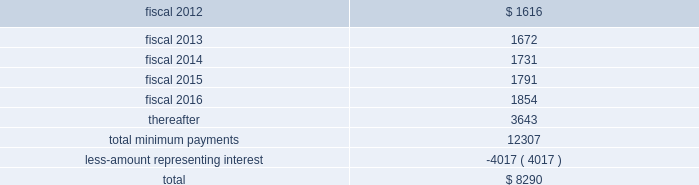Table of contents finance lease obligations the company has a non-cancelable lease agreement for a building with approximately 164000 square feet located in alajuela , costa rica , to be used as a manufacturing and office facility .
The company was responsible for a significant portion of the construction costs , and in accordance with asc 840 , leases , subsection 40-15-5 , the company was deemed to be the owner of the building during the construction period .
The building was completed in fiscal 2008 , and the company has recorded the fair market value of the building and land of $ 15.1 million within property and equipment on its consolidated balance sheets .
At september 24 , 2011 , the company has recorded $ 1.6 million in accrued expenses and $ 16.9 million in other long-term liabilities related to this obligation in the consolidated balance sheet .
The term of the lease , which commenced in may 2008 , is for a period of approximately ten years with the option to extend for two consecutive 5-year terms .
At the completion of the construction period , the company reviewed the lease for potential sale-leaseback treatment in accordance with asc 840 , subsection 40 , sale-leaseback transactions .
Based on its analysis , the company determined that the lease did not qualify for sale-leaseback treatment .
Therefore , the building , leasehold improvements and associated liabilities remain on the company 2019s financial statements throughout the lease term , and the building and leasehold improvements are being depreciated on a straight line basis over their estimated useful lives of 35 years .
Future minimum lease payments , including principal and interest , under this lease were as follows at september 24 , 2011: .
The company also has to a non-cancelable lease agreement for a building with approximately 146000 square feet located in marlborough , massachusetts , to be principally used as an additional manufacturing facility .
As part of the lease agreement , the lessor agreed to allow the company to make significant renovations to the facility to prepare the facility for the company 2019s manufacturing needs .
The company was responsible for a significant amount of the construction costs and therefore in accordance with asc 840-40-15-5 was deemed to be the owner of the building during the construction period .
The $ 13.2 million fair market value of the facility is included within property and equipment on the consolidated balance sheet .
At september 24 , 2011 , the company has recorded $ 1.0 million in accrued expenses and $ 15.9 million in other long-term liabilities related to this obligation in the consolidated balance sheet .
The term of the lease is for a period of approximately 12 years commencing on november 14 , 2006 with the option to extend for two consecutive 5-year terms .
Based on its asc 840-40 analysis , the company determined that the lease did not qualify for sale-leaseback treatment .
Therefore , the improvements and associated liabilities will remain on the company 2019s financial statements throughout the lease term , and the leasehold improvements are being depreciated on a straight line basis over their estimated useful lives of up to 35 years .
Source : hologic inc , 10-k , november 23 , 2011 powered by morningstar ae document research 2120 the information contained herein may not be copied , adapted or distributed and is not warranted to be accurate , complete or timely .
The user assumes all risks for any damages or losses arising from any use of this information , except to the extent such damages or losses cannot be limited or excluded by applicable law .
Past financial performance is no guarantee of future results. .
What portion of the total future minim lease payments is dedicated to interest payments? 
Computations: (4017 / 12307)
Answer: 0.3264. 